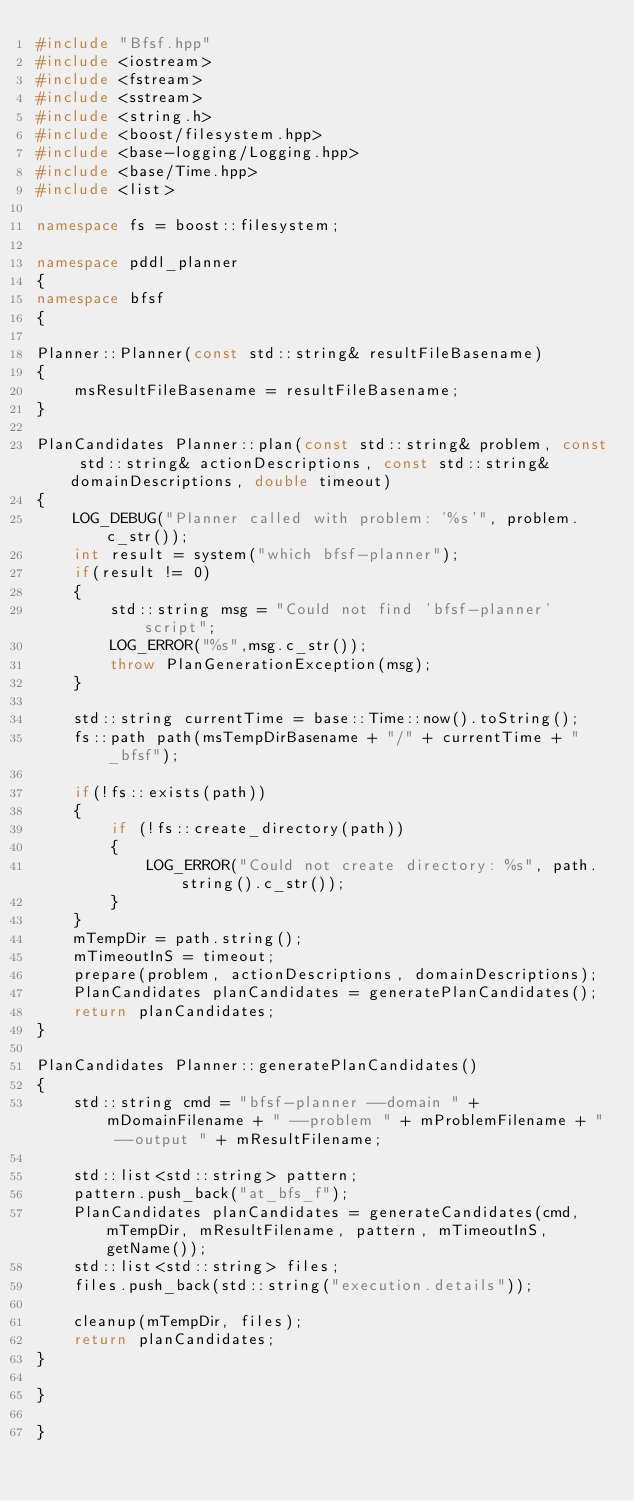<code> <loc_0><loc_0><loc_500><loc_500><_C++_>#include "Bfsf.hpp"
#include <iostream>
#include <fstream>
#include <sstream>
#include <string.h>
#include <boost/filesystem.hpp>
#include <base-logging/Logging.hpp>
#include <base/Time.hpp>
#include <list>

namespace fs = boost::filesystem;

namespace pddl_planner
{
namespace bfsf
{

Planner::Planner(const std::string& resultFileBasename)
{
    msResultFileBasename = resultFileBasename;
}

PlanCandidates Planner::plan(const std::string& problem, const std::string& actionDescriptions, const std::string& domainDescriptions, double timeout)
{
    LOG_DEBUG("Planner called with problem: '%s'", problem.c_str());
    int result = system("which bfsf-planner");
    if(result != 0)
    {
        std::string msg = "Could not find 'bfsf-planner' script";
        LOG_ERROR("%s",msg.c_str());
        throw PlanGenerationException(msg);
    }

    std::string currentTime = base::Time::now().toString();
    fs::path path(msTempDirBasename + "/" + currentTime + "_bfsf");

    if(!fs::exists(path))
    {
        if (!fs::create_directory(path))
        {
            LOG_ERROR("Could not create directory: %s", path.string().c_str());
        }
    }
    mTempDir = path.string();
    mTimeoutInS = timeout;
    prepare(problem, actionDescriptions, domainDescriptions);
    PlanCandidates planCandidates = generatePlanCandidates();
    return planCandidates;
}

PlanCandidates Planner::generatePlanCandidates()
{
    std::string cmd = "bfsf-planner --domain " + mDomainFilename + " --problem " + mProblemFilename + " --output " + mResultFilename;

    std::list<std::string> pattern;
    pattern.push_back("at_bfs_f");
    PlanCandidates planCandidates = generateCandidates(cmd, mTempDir, mResultFilename, pattern, mTimeoutInS, getName());
    std::list<std::string> files;
    files.push_back(std::string("execution.details"));

    cleanup(mTempDir, files);
    return planCandidates;
}

}

}
</code> 